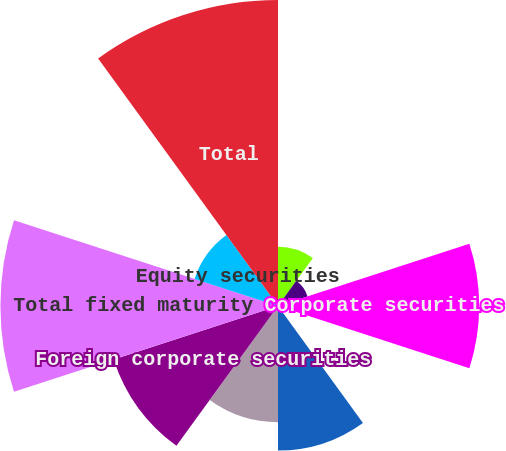<chart> <loc_0><loc_0><loc_500><loc_500><pie_chart><fcel>US government agencies and<fcel>Obligations of US states and<fcel>Corporate securities<fcel>Commercial<fcel>Agency residential<fcel>Foreign government securities<fcel>Foreign corporate securities<fcel>Total fixed maturity<fcel>Equity securities<fcel>Total<nl><fcel>4.24%<fcel>2.22%<fcel>14.38%<fcel>0.19%<fcel>10.33%<fcel>8.3%<fcel>12.35%<fcel>19.84%<fcel>6.27%<fcel>21.87%<nl></chart> 